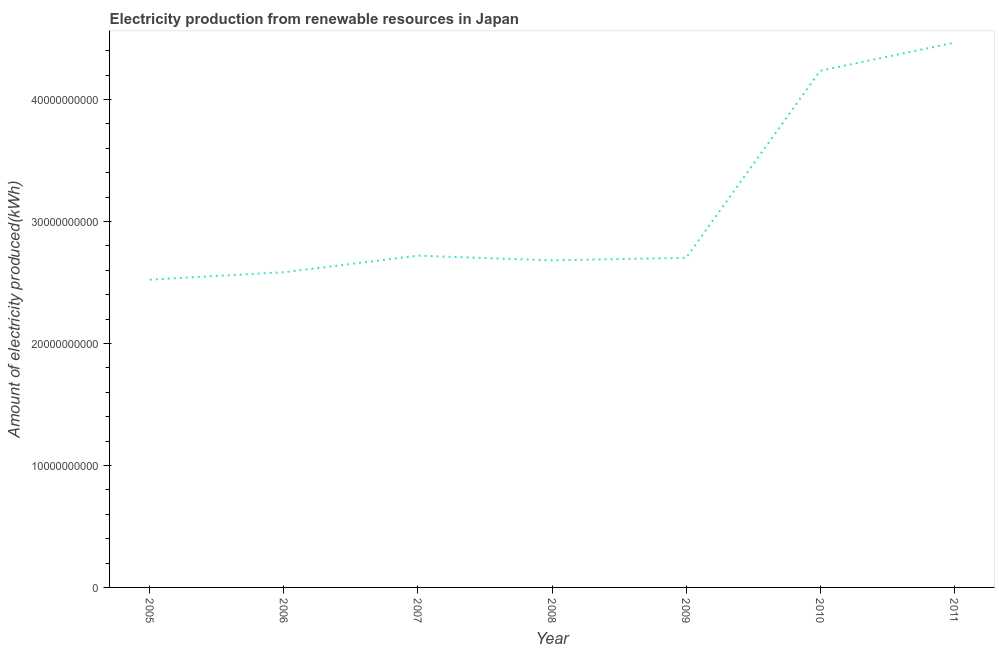What is the amount of electricity produced in 2007?
Offer a terse response. 2.72e+1. Across all years, what is the maximum amount of electricity produced?
Give a very brief answer. 4.47e+1. Across all years, what is the minimum amount of electricity produced?
Provide a succinct answer. 2.52e+1. What is the sum of the amount of electricity produced?
Your answer should be compact. 2.19e+11. What is the difference between the amount of electricity produced in 2007 and 2011?
Offer a terse response. -1.75e+1. What is the average amount of electricity produced per year?
Your answer should be compact. 3.13e+1. What is the median amount of electricity produced?
Offer a very short reply. 2.70e+1. Do a majority of the years between 2011 and 2007 (inclusive) have amount of electricity produced greater than 4000000000 kWh?
Your response must be concise. Yes. What is the ratio of the amount of electricity produced in 2005 to that in 2008?
Offer a very short reply. 0.94. Is the difference between the amount of electricity produced in 2010 and 2011 greater than the difference between any two years?
Keep it short and to the point. No. What is the difference between the highest and the second highest amount of electricity produced?
Give a very brief answer. 2.30e+09. What is the difference between the highest and the lowest amount of electricity produced?
Your response must be concise. 1.94e+1. Does the amount of electricity produced monotonically increase over the years?
Give a very brief answer. No. How many years are there in the graph?
Your answer should be very brief. 7. Does the graph contain grids?
Your answer should be very brief. No. What is the title of the graph?
Your answer should be compact. Electricity production from renewable resources in Japan. What is the label or title of the X-axis?
Offer a very short reply. Year. What is the label or title of the Y-axis?
Provide a succinct answer. Amount of electricity produced(kWh). What is the Amount of electricity produced(kWh) of 2005?
Ensure brevity in your answer.  2.52e+1. What is the Amount of electricity produced(kWh) of 2006?
Give a very brief answer. 2.58e+1. What is the Amount of electricity produced(kWh) of 2007?
Ensure brevity in your answer.  2.72e+1. What is the Amount of electricity produced(kWh) of 2008?
Your answer should be very brief. 2.68e+1. What is the Amount of electricity produced(kWh) in 2009?
Your response must be concise. 2.70e+1. What is the Amount of electricity produced(kWh) of 2010?
Your response must be concise. 4.24e+1. What is the Amount of electricity produced(kWh) of 2011?
Offer a terse response. 4.47e+1. What is the difference between the Amount of electricity produced(kWh) in 2005 and 2006?
Keep it short and to the point. -6.11e+08. What is the difference between the Amount of electricity produced(kWh) in 2005 and 2007?
Provide a short and direct response. -1.96e+09. What is the difference between the Amount of electricity produced(kWh) in 2005 and 2008?
Provide a short and direct response. -1.58e+09. What is the difference between the Amount of electricity produced(kWh) in 2005 and 2009?
Provide a succinct answer. -1.79e+09. What is the difference between the Amount of electricity produced(kWh) in 2005 and 2010?
Ensure brevity in your answer.  -1.71e+1. What is the difference between the Amount of electricity produced(kWh) in 2005 and 2011?
Your response must be concise. -1.94e+1. What is the difference between the Amount of electricity produced(kWh) in 2006 and 2007?
Provide a short and direct response. -1.35e+09. What is the difference between the Amount of electricity produced(kWh) in 2006 and 2008?
Make the answer very short. -9.71e+08. What is the difference between the Amount of electricity produced(kWh) in 2006 and 2009?
Make the answer very short. -1.18e+09. What is the difference between the Amount of electricity produced(kWh) in 2006 and 2010?
Offer a terse response. -1.65e+1. What is the difference between the Amount of electricity produced(kWh) in 2006 and 2011?
Provide a short and direct response. -1.88e+1. What is the difference between the Amount of electricity produced(kWh) in 2007 and 2008?
Provide a short and direct response. 3.82e+08. What is the difference between the Amount of electricity produced(kWh) in 2007 and 2009?
Ensure brevity in your answer.  1.71e+08. What is the difference between the Amount of electricity produced(kWh) in 2007 and 2010?
Keep it short and to the point. -1.52e+1. What is the difference between the Amount of electricity produced(kWh) in 2007 and 2011?
Your answer should be very brief. -1.75e+1. What is the difference between the Amount of electricity produced(kWh) in 2008 and 2009?
Ensure brevity in your answer.  -2.11e+08. What is the difference between the Amount of electricity produced(kWh) in 2008 and 2010?
Ensure brevity in your answer.  -1.55e+1. What is the difference between the Amount of electricity produced(kWh) in 2008 and 2011?
Ensure brevity in your answer.  -1.78e+1. What is the difference between the Amount of electricity produced(kWh) in 2009 and 2010?
Keep it short and to the point. -1.53e+1. What is the difference between the Amount of electricity produced(kWh) in 2009 and 2011?
Offer a very short reply. -1.76e+1. What is the difference between the Amount of electricity produced(kWh) in 2010 and 2011?
Make the answer very short. -2.30e+09. What is the ratio of the Amount of electricity produced(kWh) in 2005 to that in 2006?
Keep it short and to the point. 0.98. What is the ratio of the Amount of electricity produced(kWh) in 2005 to that in 2007?
Provide a short and direct response. 0.93. What is the ratio of the Amount of electricity produced(kWh) in 2005 to that in 2008?
Provide a short and direct response. 0.94. What is the ratio of the Amount of electricity produced(kWh) in 2005 to that in 2009?
Give a very brief answer. 0.93. What is the ratio of the Amount of electricity produced(kWh) in 2005 to that in 2010?
Ensure brevity in your answer.  0.6. What is the ratio of the Amount of electricity produced(kWh) in 2005 to that in 2011?
Your answer should be compact. 0.56. What is the ratio of the Amount of electricity produced(kWh) in 2006 to that in 2007?
Make the answer very short. 0.95. What is the ratio of the Amount of electricity produced(kWh) in 2006 to that in 2008?
Make the answer very short. 0.96. What is the ratio of the Amount of electricity produced(kWh) in 2006 to that in 2009?
Provide a short and direct response. 0.96. What is the ratio of the Amount of electricity produced(kWh) in 2006 to that in 2010?
Make the answer very short. 0.61. What is the ratio of the Amount of electricity produced(kWh) in 2006 to that in 2011?
Provide a short and direct response. 0.58. What is the ratio of the Amount of electricity produced(kWh) in 2007 to that in 2009?
Provide a succinct answer. 1.01. What is the ratio of the Amount of electricity produced(kWh) in 2007 to that in 2010?
Make the answer very short. 0.64. What is the ratio of the Amount of electricity produced(kWh) in 2007 to that in 2011?
Keep it short and to the point. 0.61. What is the ratio of the Amount of electricity produced(kWh) in 2008 to that in 2010?
Keep it short and to the point. 0.63. What is the ratio of the Amount of electricity produced(kWh) in 2009 to that in 2010?
Your answer should be very brief. 0.64. What is the ratio of the Amount of electricity produced(kWh) in 2009 to that in 2011?
Your answer should be compact. 0.6. What is the ratio of the Amount of electricity produced(kWh) in 2010 to that in 2011?
Your answer should be very brief. 0.95. 